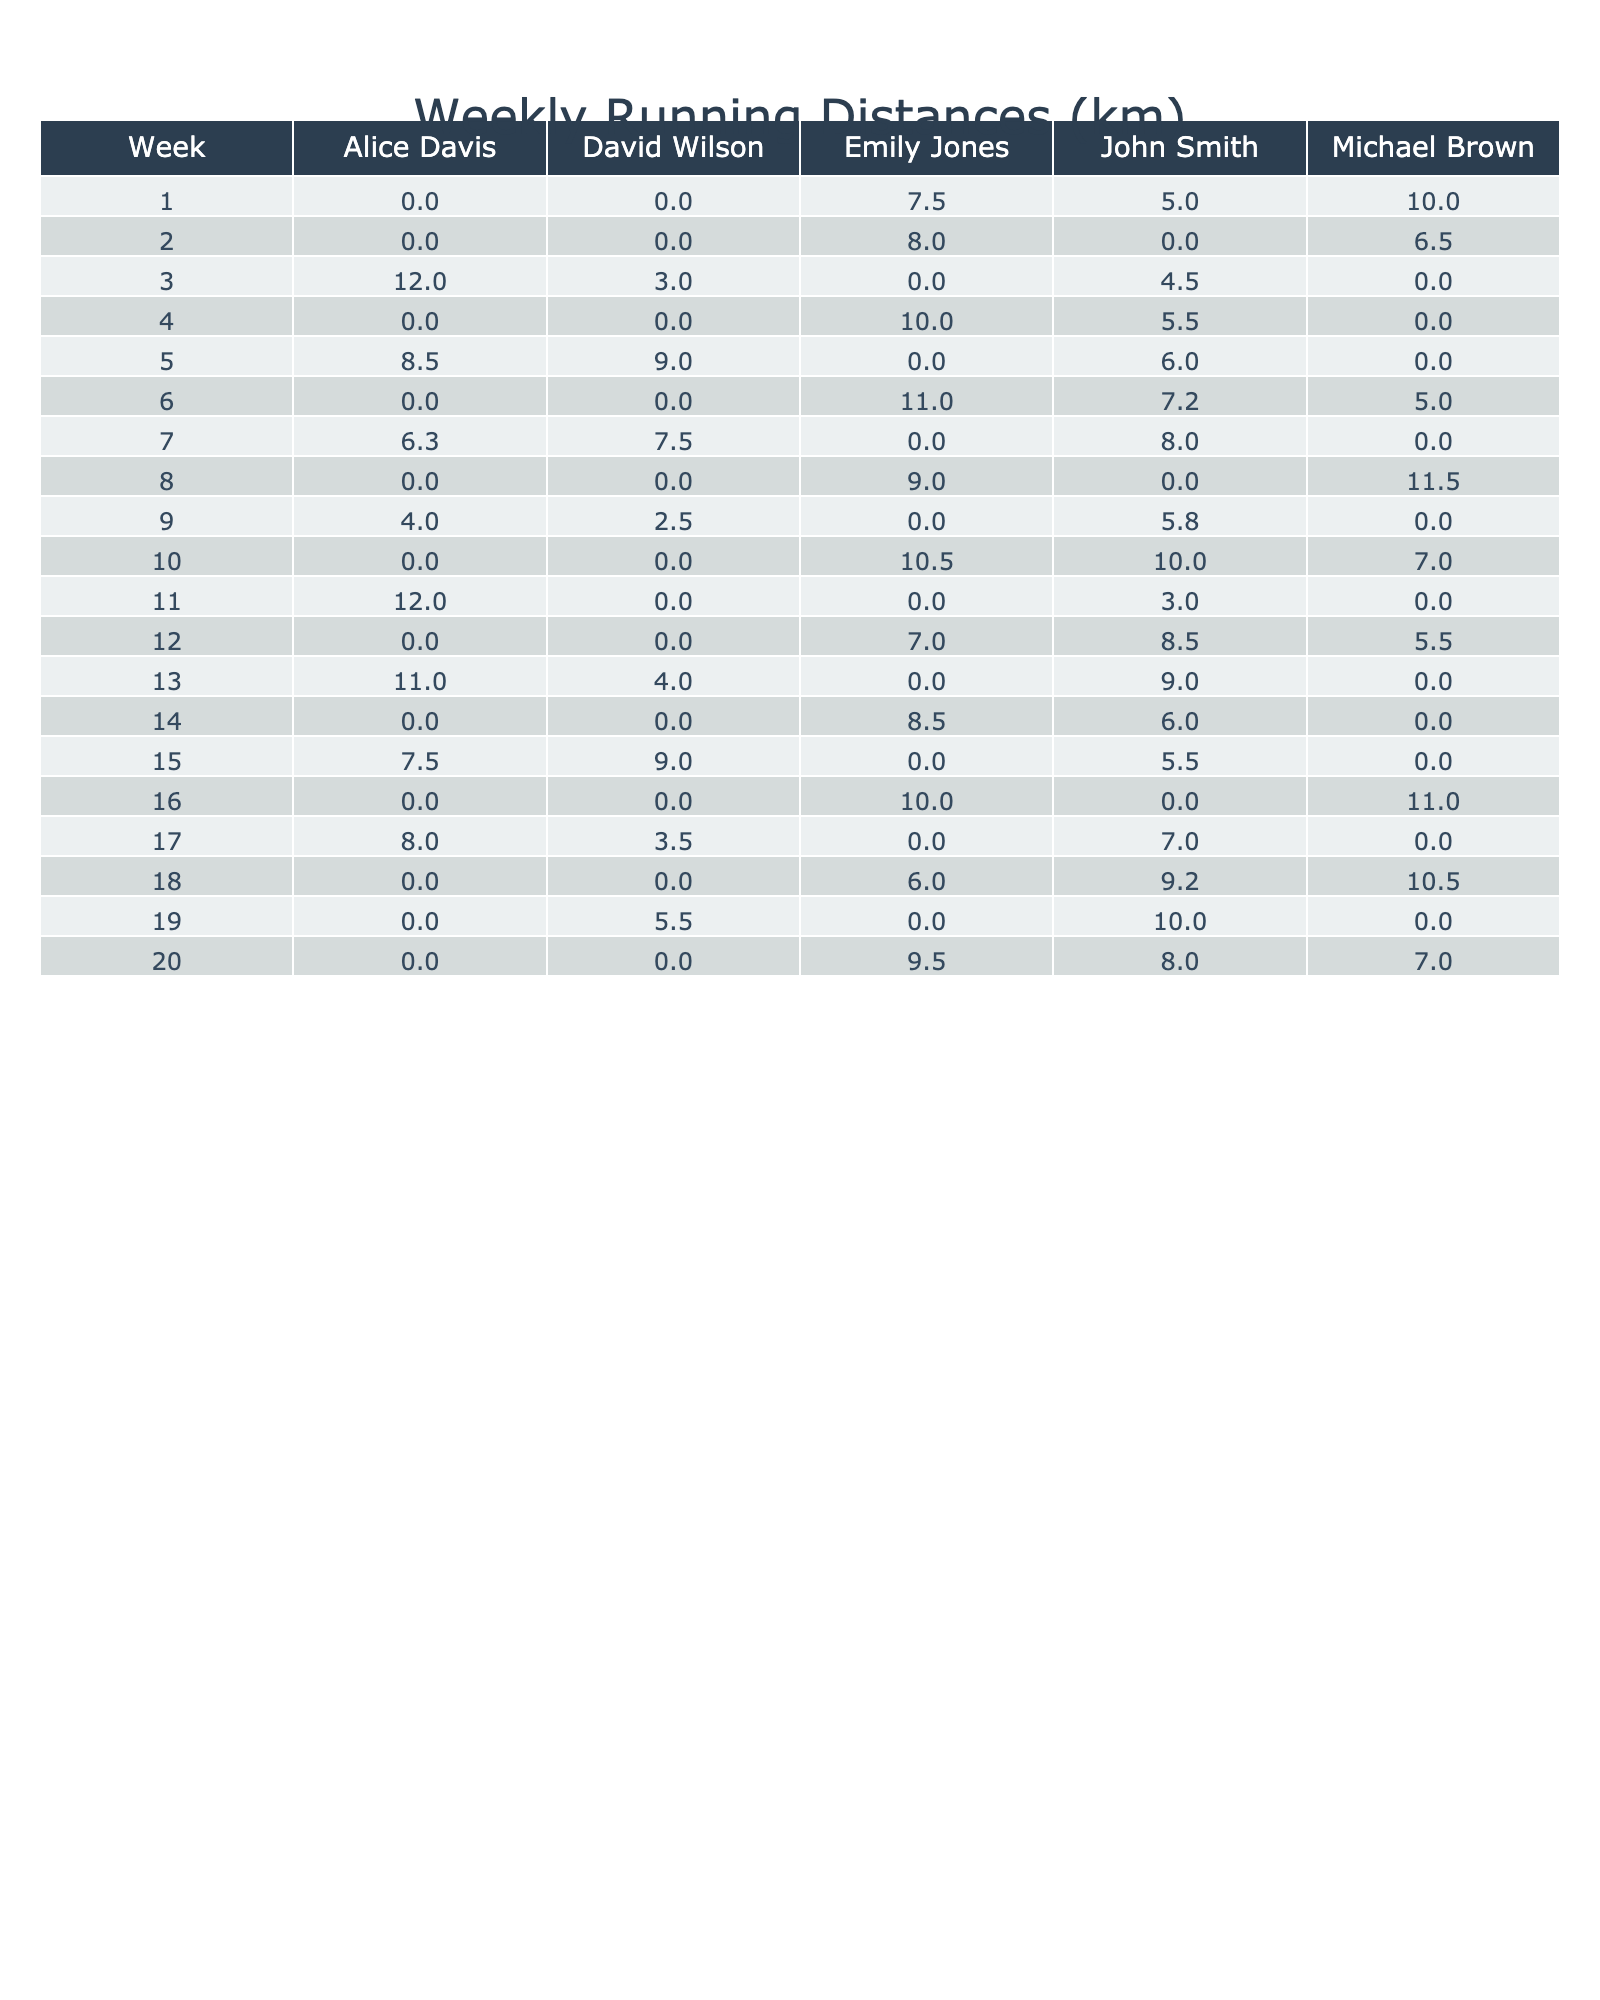What was John Smith's running distance in Week 5? In Week 5, looking at the table, the value for John Smith under Running Distance is 6.0 km.
Answer: 6.0 km How many kilometers did Emily Jones run in total over the 20 weeks? To find the total for Emily Jones, we sum her distances from each week: 7.5 + 8.0 + 10.0 + 11.0 + 9.0 + 10.5 + 7.0 + 8.5 + 10.0 + 6.0 + 9.5 = 88.5 km.
Answer: 88.5 km Did Michael Brown run any distance in Week 4? In Week 4, the table shows that Michael Brown's running distance is 0 km, which indicates he did not run that week.
Answer: No What is the average running distance for Alice Davis over the last 20 weeks? Alice Davis's distances are: 12.0, 8.5, 6.3, 0, 12.0, 11.0, 7.5, 8.0, 0. The total is 12.0 + 8.5 + 6.3 + 0 + 12.0 + 11.0 + 7.5 + 8.0 + 0 = 64.3 km. Dividing by the number of weeks she ran (8 weeks), the average is 64.3 / 8 = 8.04 km.
Answer: 8.04 km Which member logged the highest running distance in Week 12? In Week 12, by checking the distances, John Smith ran 8.5 km, Emily Jones ran 7.0 km, and Michael Brown ran 5.5 km. John Smith logged the highest distance at 8.5 km.
Answer: John Smith What is the total distance run by David Wilson over the 20 weeks? David Wilson's distances are: 3.0, 9.0, 7.5, 2.5, 0, 4.0, 9.0, 5.5. Adding them results in 3.0 + 9.0 + 7.5 + 2.5 + 0 + 4.0 + 9.0 + 5.5 = 40.5 km.
Answer: 40.5 km In which week did John Smith have the lowest running distance? By examining the distances for John Smith across the weeks, Week 2 has a running distance of 0 km, which is the lowest.
Answer: Week 2 How many weeks did Emily Jones run more than 8 km? Checking Emily Jones's distances: Weeks 1 (7.5), 2 (8.0), 4 (10.0), 6 (11.0), 8 (9.0), 10 (10.5), 12 (7.0), 14 (8.5), 16 (10.0), 18 (6.0), 20 (9.5). She ran more than 8 km in Weeks 4, 6, 8, 10, 14, 16, and 20, totaling 6 weeks.
Answer: 6 weeks What was the increase in John Smith's running distance from Week 1 to Week 10? In Week 1, John ran 5.0 km, and in Week 10, he ran 10.0 km. The increase is calculated as 10.0 km - 5.0 km = 5.0 km.
Answer: 5.0 km Which member had the most inconsistent running pattern, as indicated by missed weeks? In reviewing attendance, John Smith had a gap in Weeks 2, 8, and 16 where he ran 0 km. Thus, he had the most inconsistent pattern with three weeks of missed runs.
Answer: John Smith 